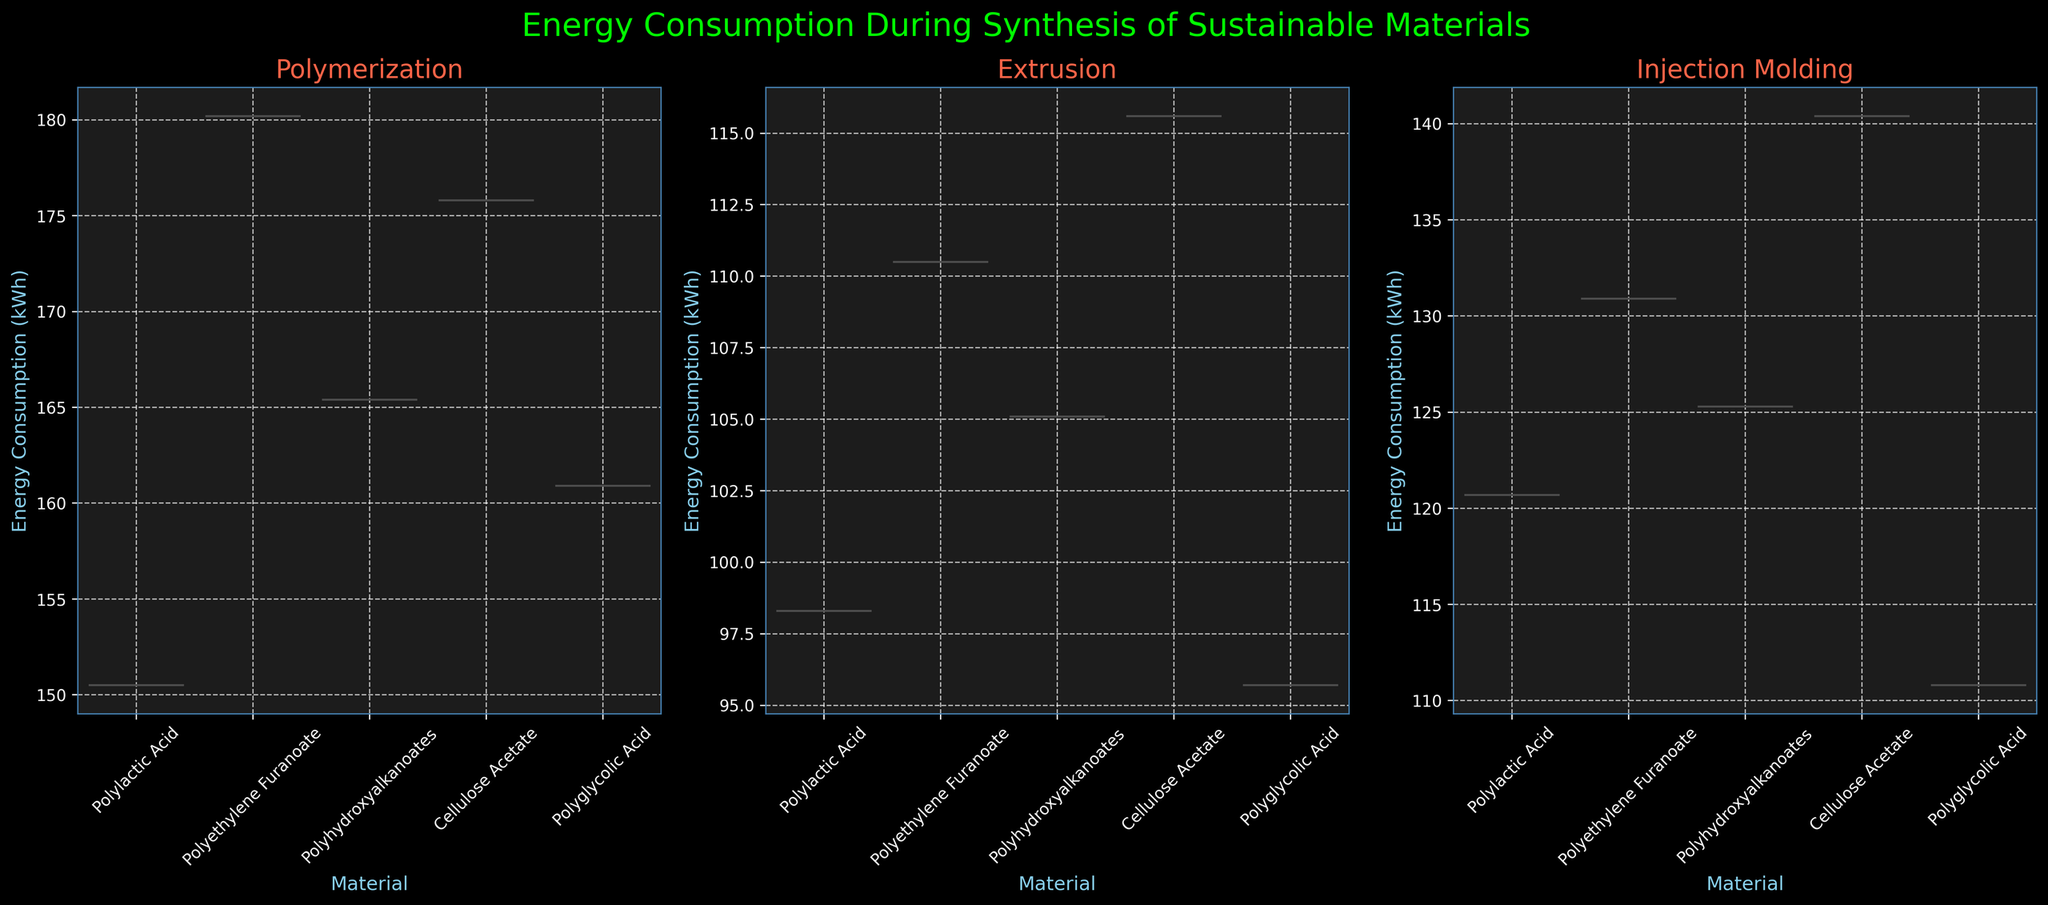What is the title of the figure? The title is generally located at the top of the figure, and it summarizes the figure’s content. Here it reads 'Energy Consumption During Synthesis of Sustainable Materials'.
Answer: Energy Consumption During Synthesis of Sustainable Materials How many synthesis types are compared in the figure? There are three subplots corresponding to different synthesis types as per the information provided. Each subplot shows a different synthesis type.
Answer: Three Which synthesis type shows the highest median energy consumption for Polylactic Acid? To determine this, look at the medians (typically the central white dot or line in each violin plot) for Polylactic Acid in each of the three synthesis types. Here it is highest in Polymerization.
Answer: Polymerization What is the overall trend in energy consumption among different synthesis types for Polyethylene Furanoate? Examine the three violin plots for Polyethylene Furanoate. Polymerization has the highest median energy consumption, followed by Injection Molding, and then Extrusion.
Answer: Polymerization > Injection Molding > Extrusion Which synthesis type exhibits the highest range of energy consumption for any material? The range of a violin plot can be inferred from its height. Look for the plot with the highest vertical span. The Polymerization subplot for Polyethylene Furanoate seems to show the highest range.
Answer: Polymerization for Polyethylene Furanoate Compare the median energy consumption values of Cellulose Acetate for Extrusion and Injection Molding. Which one is higher? Look at the central part of the violin plots for Cellulose Acetate under Extrusion and Injection Molding. The Injection Molding median appears higher than that of Extrusion.
Answer: Injection Molding Which material shows the smallest difference in median energy consumption between Polymerization and Injection Molding? Look at the medians for Polymerization and Injection Molding for each material and identify the smallest difference. Polyhydroxyalkanoates have the least difference in median values.
Answer: Polyhydroxyalkanoates Identify the synthesis type where Polyglycolic Acid has the lowest energy consumption. By observing the three violin plots for Polyglycolic Acid, the Extrusion plot shows the lowest median energy consumption.
Answer: Extrusion Which material exhibits the most variability in energy consumption during Injection Molding? The material with the widest or most spread-out Injection Molding violin plot displays the most variability. Cellulose Acetate seems to show the most variability.
Answer: Cellulose Acetate 